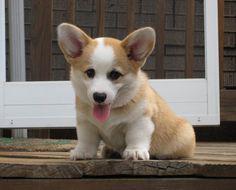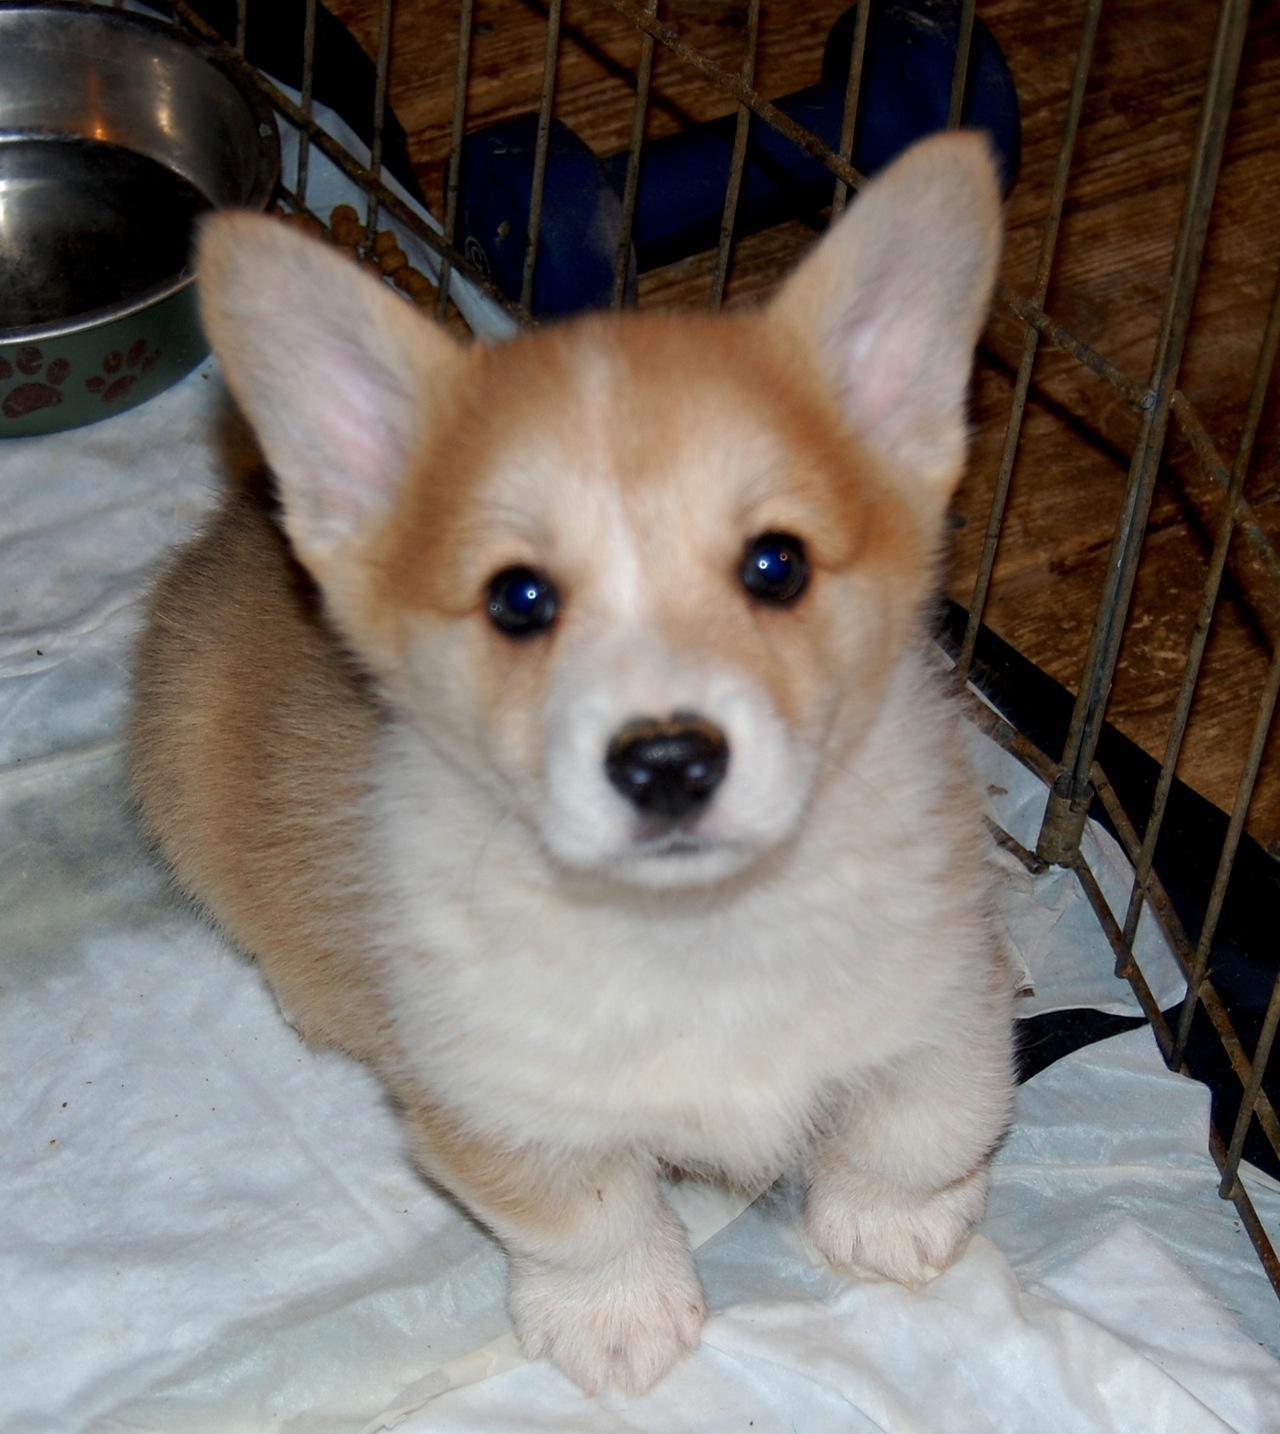The first image is the image on the left, the second image is the image on the right. Assess this claim about the two images: "In at least one of the photos, a dog's body is facing left.". Correct or not? Answer yes or no. No. The first image is the image on the left, the second image is the image on the right. For the images displayed, is the sentence "In one of the images, a dog can be seen wearing a collar." factually correct? Answer yes or no. No. 